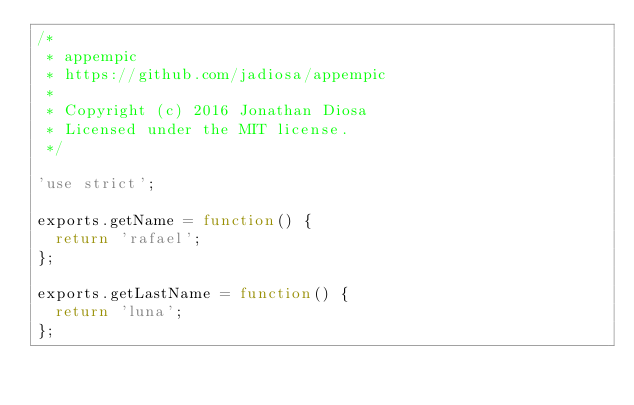Convert code to text. <code><loc_0><loc_0><loc_500><loc_500><_JavaScript_>/*
 * appempic
 * https://github.com/jadiosa/appempic
 *
 * Copyright (c) 2016 Jonathan Diosa
 * Licensed under the MIT license.
 */

'use strict';

exports.getName = function() {
  return 'rafael';
};

exports.getLastName = function() {
  return 'luna';
};</code> 